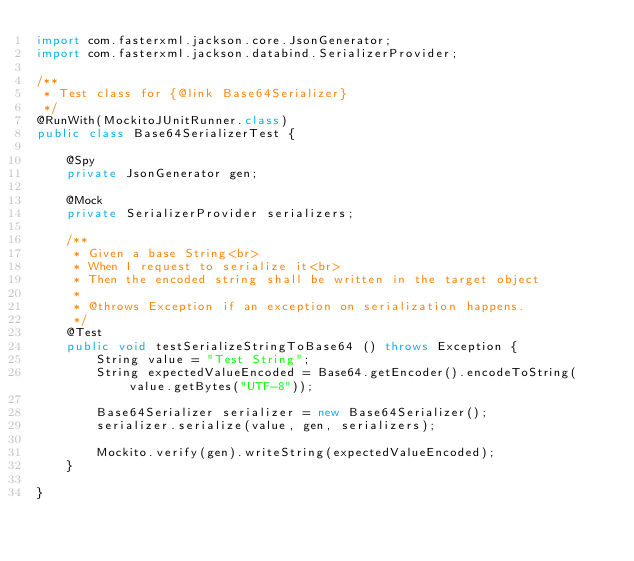Convert code to text. <code><loc_0><loc_0><loc_500><loc_500><_Java_>import com.fasterxml.jackson.core.JsonGenerator;
import com.fasterxml.jackson.databind.SerializerProvider;

/**
 * Test class for {@link Base64Serializer}
 */
@RunWith(MockitoJUnitRunner.class)
public class Base64SerializerTest {

    @Spy
    private JsonGenerator gen;

    @Mock
    private SerializerProvider serializers;

    /**
     * Given a base String<br>
     * When I request to serialize it<br>
     * Then the encoded string shall be written in the target object
     *
     * @throws Exception if an exception on serialization happens.
     */
    @Test
    public void testSerializeStringToBase64 () throws Exception {
        String value = "Test String";
        String expectedValueEncoded = Base64.getEncoder().encodeToString(value.getBytes("UTF-8"));

        Base64Serializer serializer = new Base64Serializer();
        serializer.serialize(value, gen, serializers);

        Mockito.verify(gen).writeString(expectedValueEncoded);
    }

}
</code> 